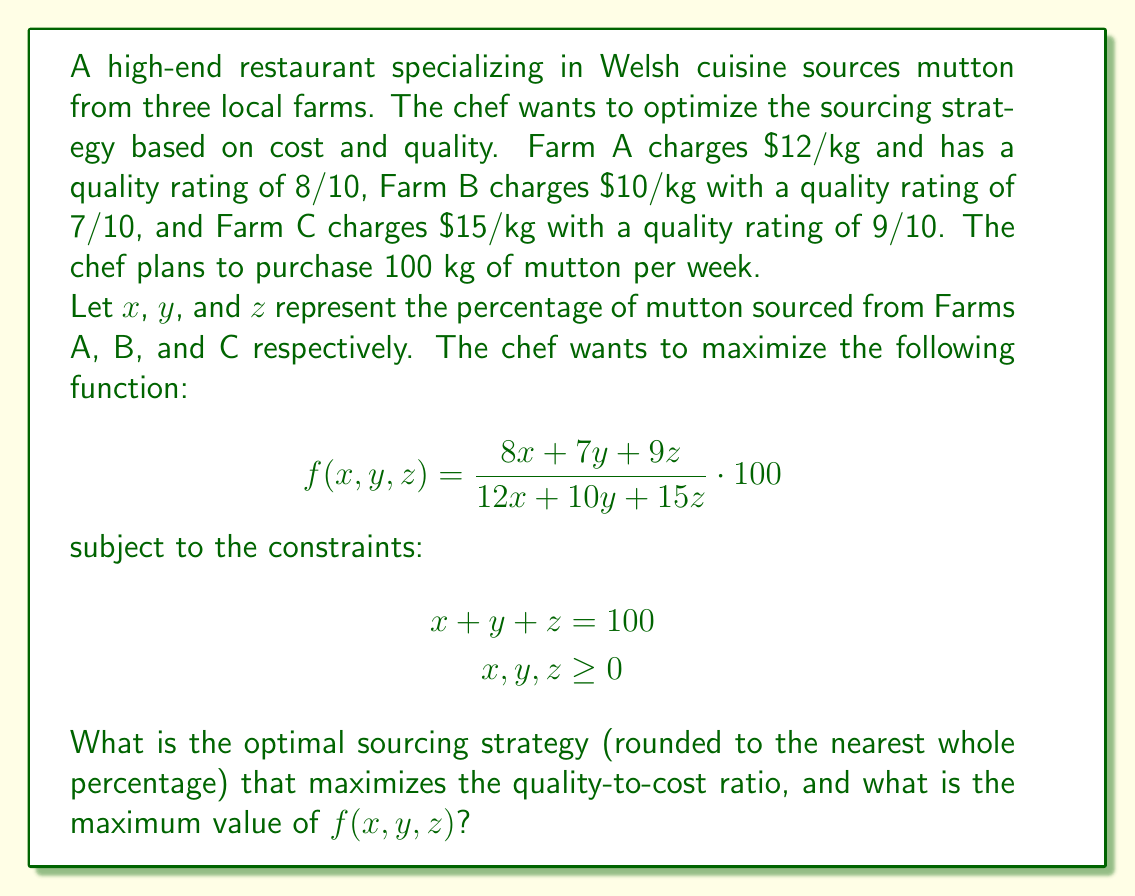Solve this math problem. To solve this optimization problem, we can use the method of Lagrange multipliers. However, due to the constraints and the nature of the function, we can simplify our approach:

1) First, note that Farm C has the highest quality-to-cost ratio:
   $\frac{9}{15} = 0.6$

2) Farm A has the second-highest ratio:
   $\frac{8}{12} \approx 0.667$

3) Farm B has the lowest ratio:
   $\frac{7}{10} = 0.7$

4) Given these ratios, to maximize $f(x,y,z)$, we should source as much as possible from Farm B, then Farm A, and finally Farm C.

5) Therefore, the optimal strategy is to source 100% from Farm B:
   $x = 0, y = 100, z = 0$

6) Substituting these values into the original function:

   $$f(0,100,0) = \frac{7 \cdot 100}{10 \cdot 100} \cdot 100 = 70$$

This gives us the maximum value of the function.

To verify, we can check the value of $f(x,y,z)$ for sourcing 100% from Farm A or Farm C:

For Farm A: $f(100,0,0) = \frac{8 \cdot 100}{12 \cdot 100} \cdot 100 \approx 66.67$
For Farm C: $f(0,0,100) = \frac{9 \cdot 100}{15 \cdot 100} \cdot 100 = 60$

These values are indeed lower than sourcing 100% from Farm B.
Answer: The optimal sourcing strategy is to source 100% from Farm B (0% from Farm A, 100% from Farm B, 0% from Farm C). The maximum value of $f(x,y,z)$ is 70. 